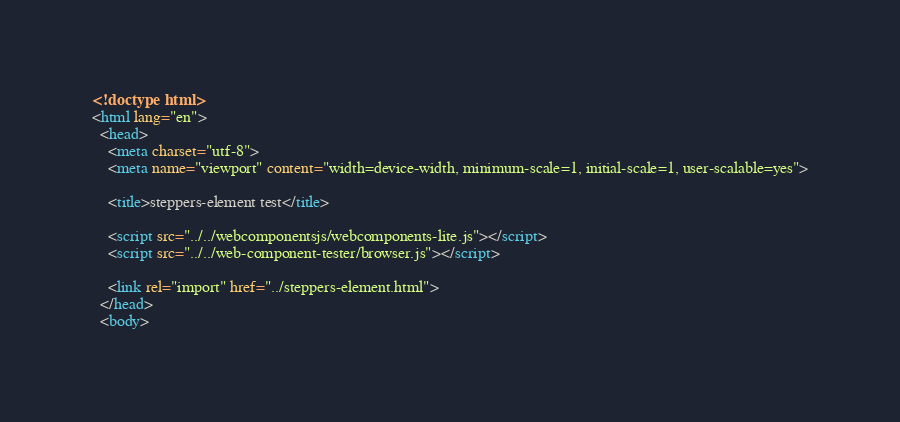<code> <loc_0><loc_0><loc_500><loc_500><_HTML_><!doctype html>
<html lang="en">
  <head>
    <meta charset="utf-8">
    <meta name="viewport" content="width=device-width, minimum-scale=1, initial-scale=1, user-scalable=yes">

    <title>steppers-element test</title>

    <script src="../../webcomponentsjs/webcomponents-lite.js"></script>
    <script src="../../web-component-tester/browser.js"></script>

    <link rel="import" href="../steppers-element.html">
  </head>
  <body>
</code> 